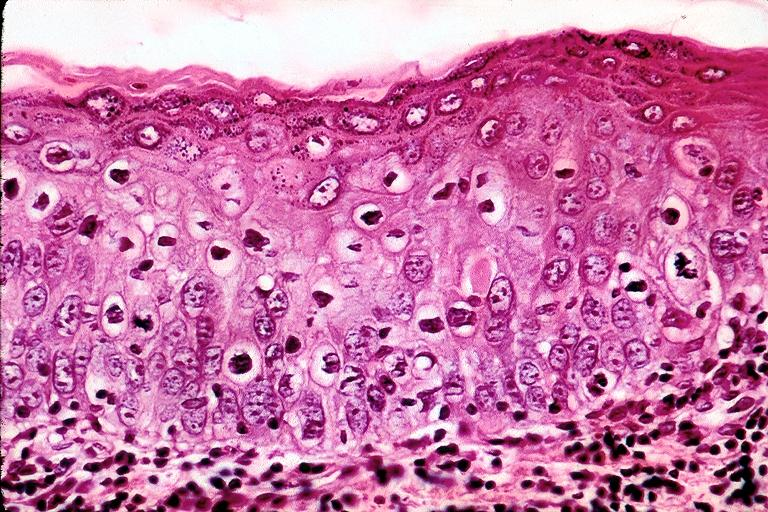s close-up of lesion present?
Answer the question using a single word or phrase. No 